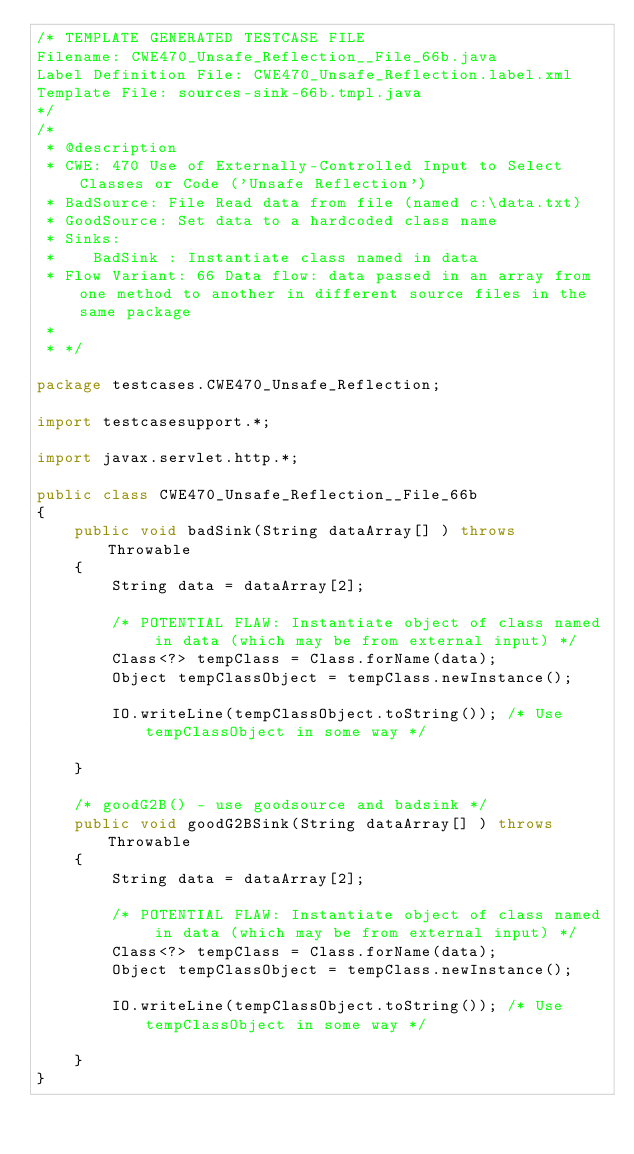Convert code to text. <code><loc_0><loc_0><loc_500><loc_500><_Java_>/* TEMPLATE GENERATED TESTCASE FILE
Filename: CWE470_Unsafe_Reflection__File_66b.java
Label Definition File: CWE470_Unsafe_Reflection.label.xml
Template File: sources-sink-66b.tmpl.java
*/
/*
 * @description
 * CWE: 470 Use of Externally-Controlled Input to Select Classes or Code ('Unsafe Reflection')
 * BadSource: File Read data from file (named c:\data.txt)
 * GoodSource: Set data to a hardcoded class name
 * Sinks:
 *    BadSink : Instantiate class named in data
 * Flow Variant: 66 Data flow: data passed in an array from one method to another in different source files in the same package
 *
 * */

package testcases.CWE470_Unsafe_Reflection;

import testcasesupport.*;

import javax.servlet.http.*;

public class CWE470_Unsafe_Reflection__File_66b
{
    public void badSink(String dataArray[] ) throws Throwable
    {
        String data = dataArray[2];

        /* POTENTIAL FLAW: Instantiate object of class named in data (which may be from external input) */
        Class<?> tempClass = Class.forName(data);
        Object tempClassObject = tempClass.newInstance();

        IO.writeLine(tempClassObject.toString()); /* Use tempClassObject in some way */

    }

    /* goodG2B() - use goodsource and badsink */
    public void goodG2BSink(String dataArray[] ) throws Throwable
    {
        String data = dataArray[2];

        /* POTENTIAL FLAW: Instantiate object of class named in data (which may be from external input) */
        Class<?> tempClass = Class.forName(data);
        Object tempClassObject = tempClass.newInstance();

        IO.writeLine(tempClassObject.toString()); /* Use tempClassObject in some way */

    }
}
</code> 